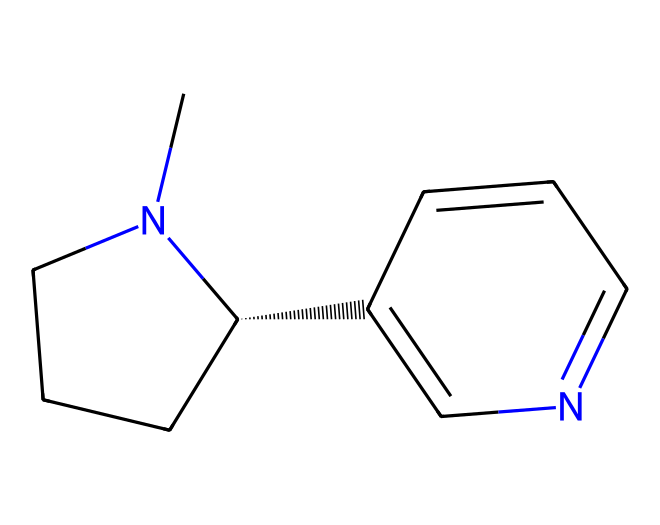What is the molecular formula of nicotine? The molecular formula can be determined from the SMILES representation by counting the number of carbon (C), hydrogen (H), and nitrogen (N) atoms. In this case, there are 10 carbon atoms, 14 hydrogen atoms, and 2 nitrogen atoms. Therefore, the molecular formula is C10H14N2.
Answer: C10H14N2 How many rings are present in the nicotine structure? Analyzing the SMILES, there are two cyclic structures that can be identified from the usage of 'C' and 'N'. One is a piperidine ring (six-membered) and the other is a pyridine ring (five-membered). Thus, there are two rings in total.
Answer: 2 What type of compound is nicotine primarily classified as? Nicotine contains nitrogen and has complex cyclic structures characteristic of alkaloids, which are naturally occurring chemical compounds. This structural feature clearly identifies it as a bioactive alkaloid.
Answer: alkaloid What functional groups are present in nicotine? The structure includes a nitrogen atom that is part of both rings. In this case, the presence of these nitrogen atoms and their specific arrangement classifies it under the umbrella of amines and heterocycles, since both are part of the structure. The compound lacks other functional groups like alcohols or carboxylic acids.
Answer: amine, heterocycle How does the arrangement of atoms in nicotine contribute to its addictive properties? The structure's specific arrangement, including the piperidine and pyridine rings and the nitrogen atoms, allows nicotine to effectively bind to acetylcholine receptors in the brain, thus stimulating dopamine release. This is a crucial factor in its addictive nature, as it affects neurotransmitter levels.
Answer: receptor binding 